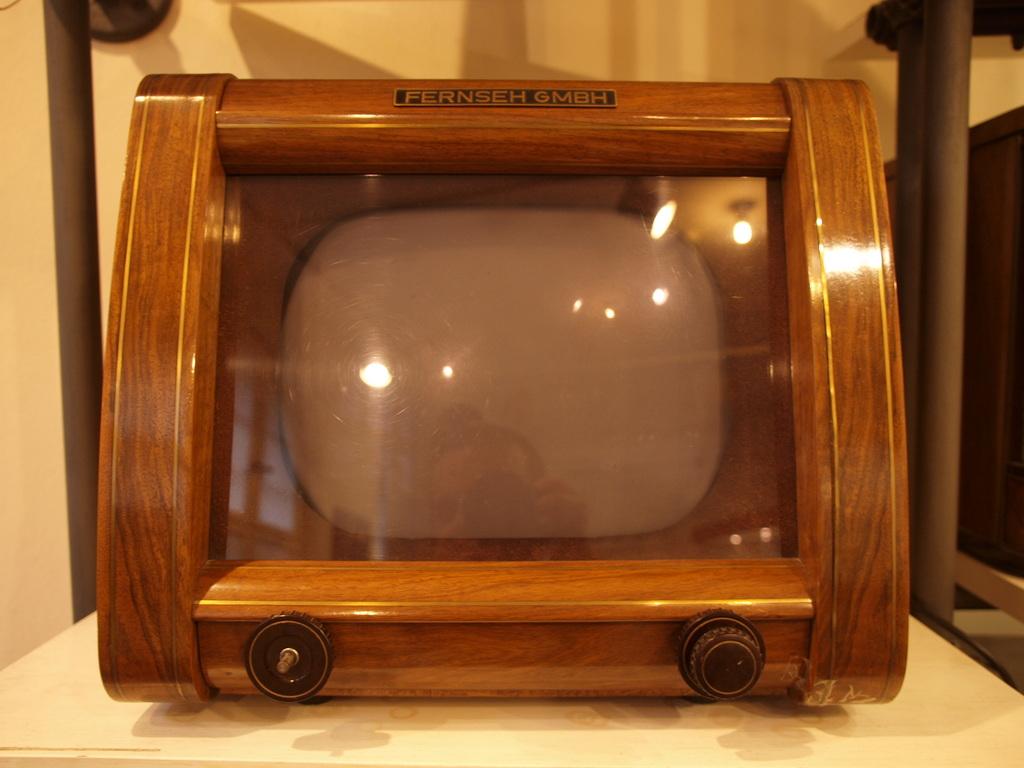What does the top of the item say?
Provide a short and direct response. Fernseh gmbh. 